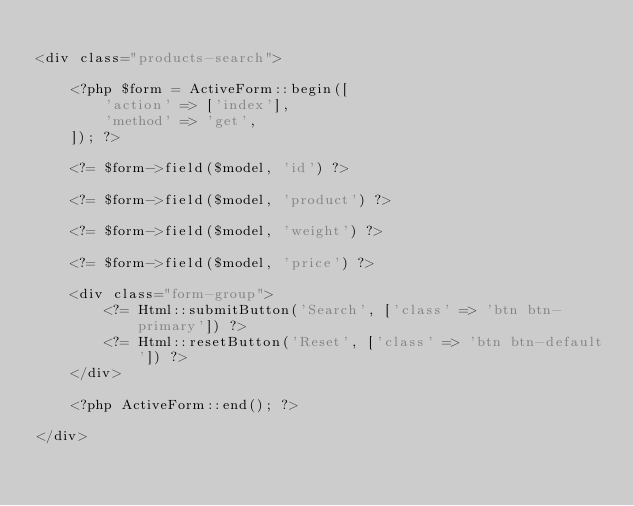<code> <loc_0><loc_0><loc_500><loc_500><_PHP_>
<div class="products-search">

    <?php $form = ActiveForm::begin([
        'action' => ['index'],
        'method' => 'get',
    ]); ?>

    <?= $form->field($model, 'id') ?>

    <?= $form->field($model, 'product') ?>

    <?= $form->field($model, 'weight') ?>

    <?= $form->field($model, 'price') ?>

    <div class="form-group">
        <?= Html::submitButton('Search', ['class' => 'btn btn-primary']) ?>
        <?= Html::resetButton('Reset', ['class' => 'btn btn-default']) ?>
    </div>

    <?php ActiveForm::end(); ?>

</div>
</code> 